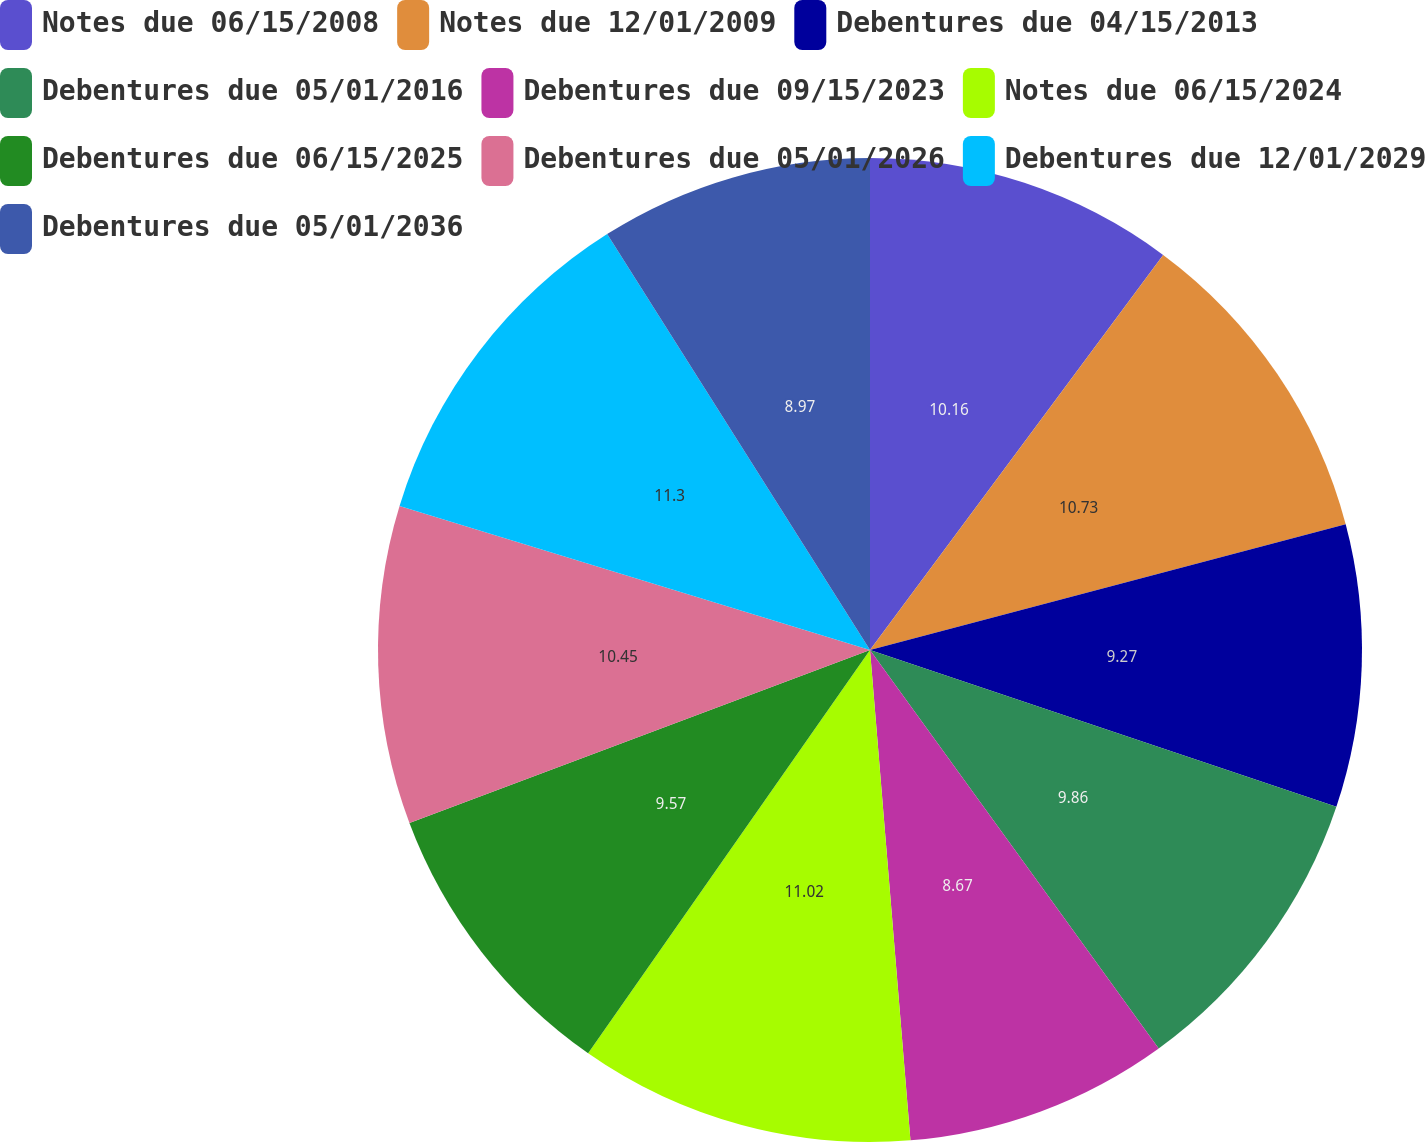Convert chart to OTSL. <chart><loc_0><loc_0><loc_500><loc_500><pie_chart><fcel>Notes due 06/15/2008<fcel>Notes due 12/01/2009<fcel>Debentures due 04/15/2013<fcel>Debentures due 05/01/2016<fcel>Debentures due 09/15/2023<fcel>Notes due 06/15/2024<fcel>Debentures due 06/15/2025<fcel>Debentures due 05/01/2026<fcel>Debentures due 12/01/2029<fcel>Debentures due 05/01/2036<nl><fcel>10.16%<fcel>10.73%<fcel>9.27%<fcel>9.86%<fcel>8.67%<fcel>11.02%<fcel>9.57%<fcel>10.45%<fcel>11.3%<fcel>8.97%<nl></chart> 